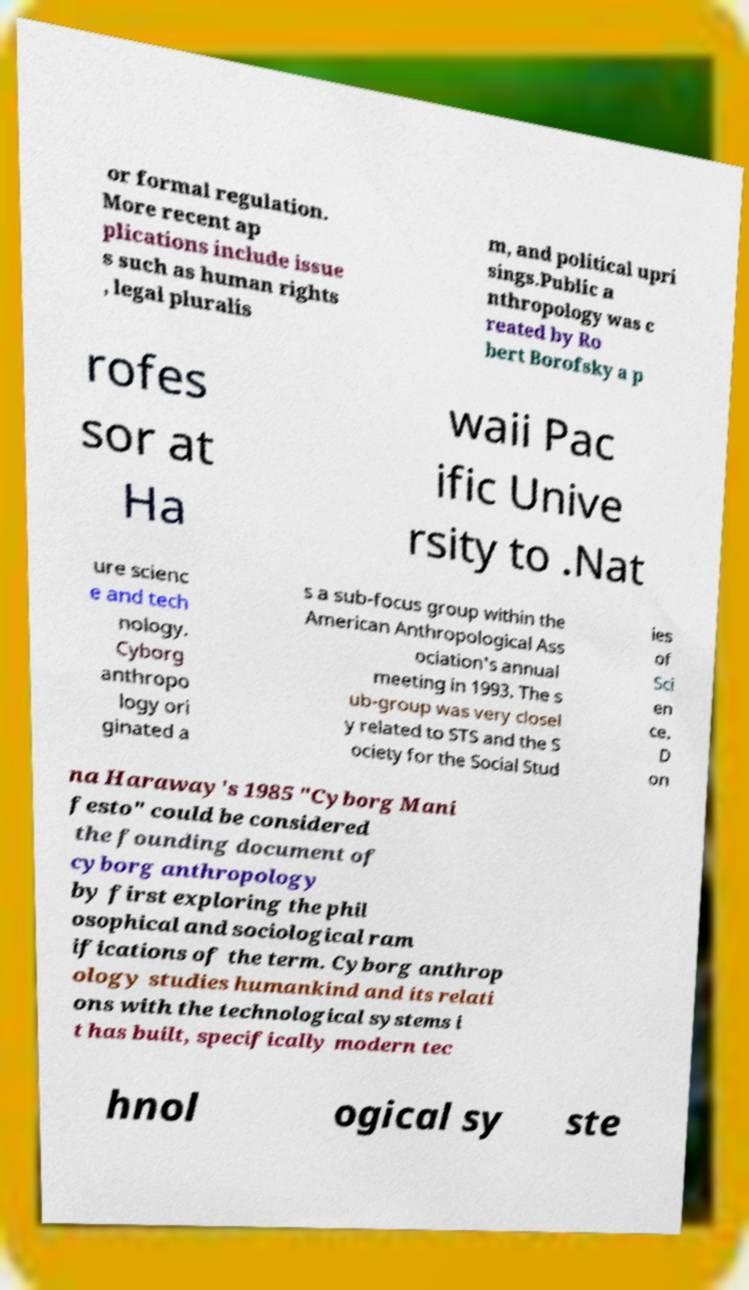What messages or text are displayed in this image? I need them in a readable, typed format. or formal regulation. More recent ap plications include issue s such as human rights , legal pluralis m, and political upri sings.Public a nthropology was c reated by Ro bert Borofsky a p rofes sor at Ha waii Pac ific Unive rsity to .Nat ure scienc e and tech nology. Cyborg anthropo logy ori ginated a s a sub-focus group within the American Anthropological Ass ociation's annual meeting in 1993. The s ub-group was very closel y related to STS and the S ociety for the Social Stud ies of Sci en ce. D on na Haraway's 1985 "Cyborg Mani festo" could be considered the founding document of cyborg anthropology by first exploring the phil osophical and sociological ram ifications of the term. Cyborg anthrop ology studies humankind and its relati ons with the technological systems i t has built, specifically modern tec hnol ogical sy ste 